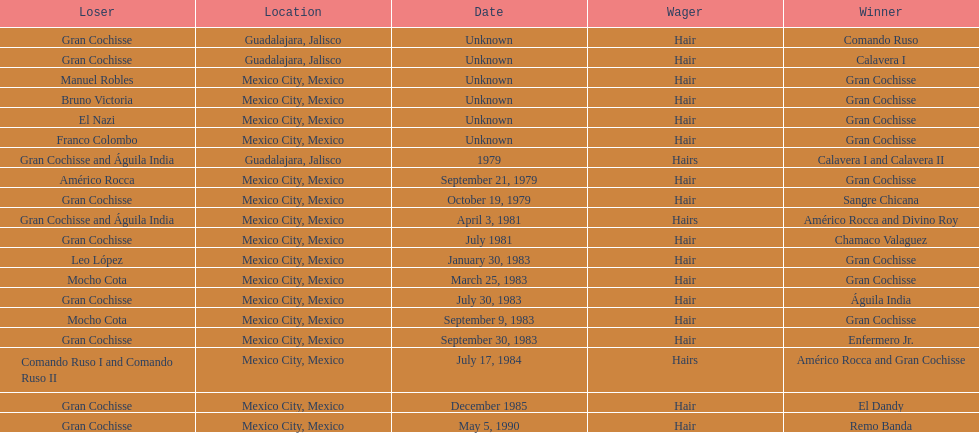How many winners were there before bruno victoria lost? 3. 